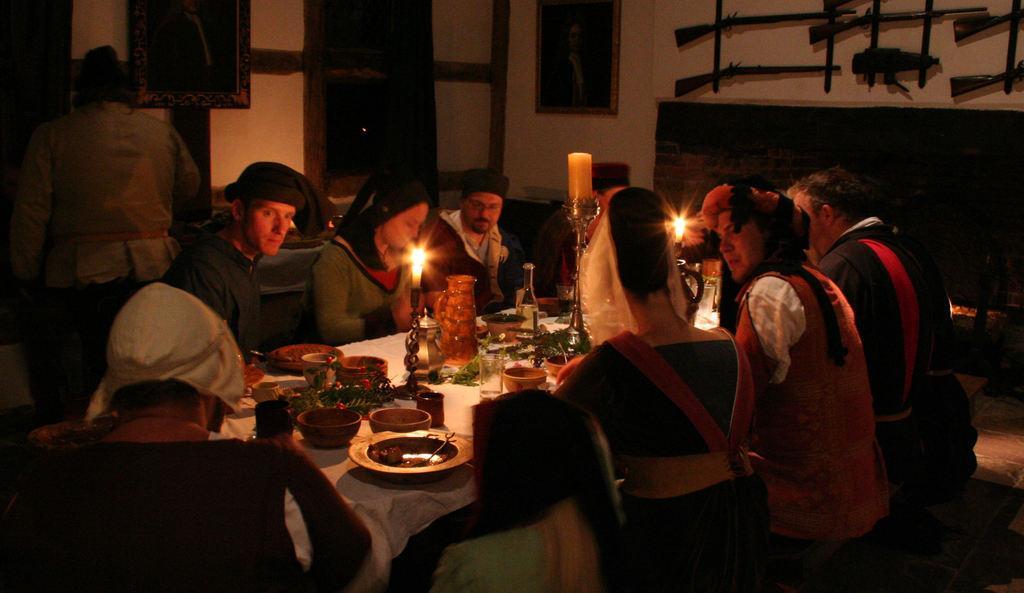In one or two sentences, can you explain what this image depicts? In this image we can see few people sitting on the chairs near dining table. There are food items, bowls, plates, glasses, candle holders and candles on the top of the table. In the background of the image we can see guns hanged on the wall, few photo frames. 